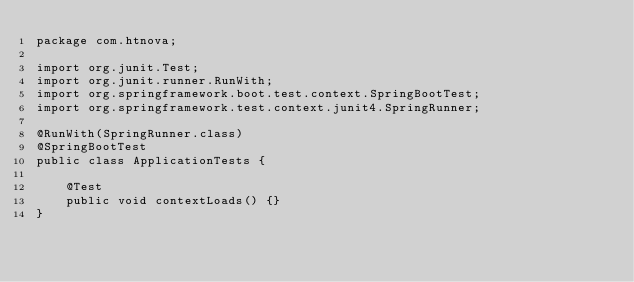Convert code to text. <code><loc_0><loc_0><loc_500><loc_500><_Java_>package com.htnova;

import org.junit.Test;
import org.junit.runner.RunWith;
import org.springframework.boot.test.context.SpringBootTest;
import org.springframework.test.context.junit4.SpringRunner;

@RunWith(SpringRunner.class)
@SpringBootTest
public class ApplicationTests {

    @Test
    public void contextLoads() {}
}
</code> 